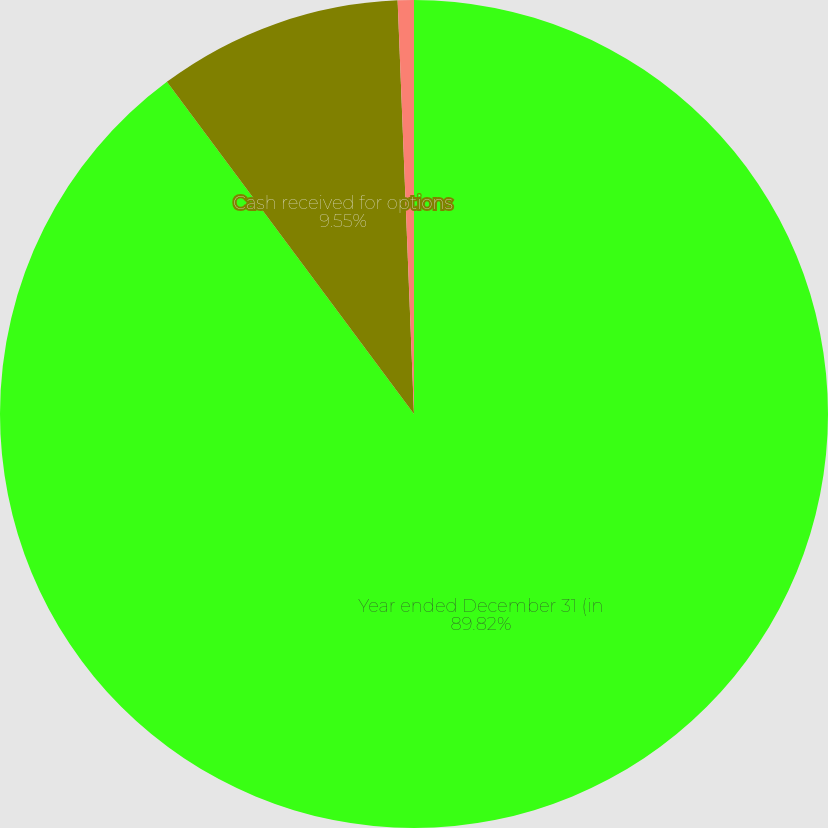Convert chart. <chart><loc_0><loc_0><loc_500><loc_500><pie_chart><fcel>Year ended December 31 (in<fcel>Cash received for options<fcel>Tax benefit realized<nl><fcel>89.83%<fcel>9.55%<fcel>0.63%<nl></chart> 